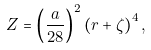<formula> <loc_0><loc_0><loc_500><loc_500>Z = \left ( \frac { a } { 2 8 } \right ) ^ { 2 } \left ( r + \zeta \right ) ^ { 4 } ,</formula> 